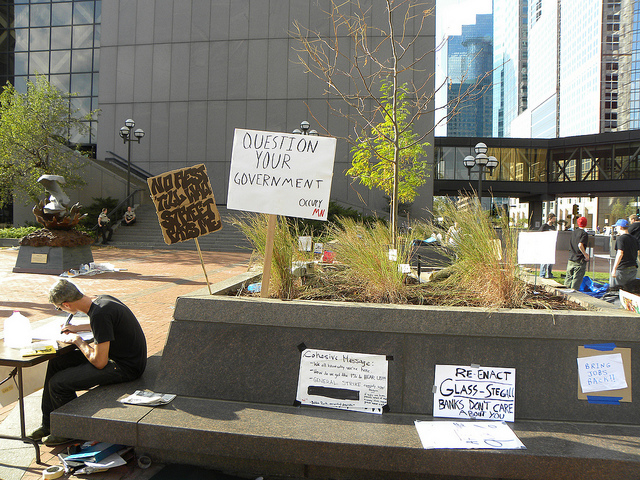What might the signs and writing on the cardboard suggest about the issues being addressed in this protest? The signs make references to government scrutiny and financial reform, which are often rallying points for protestors seeking change in public policy. 'QUESTION YOUR GOVERNMENT' encourages citizens to critically evaluate governmental actions, while 'Re-enact Glass-Steagall' points to a specific legislative action that intended to regulate banking and finance. Collectively, these elements suggest that the protest is likely focused on societal governance and financial sector accountability. 